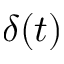<formula> <loc_0><loc_0><loc_500><loc_500>\delta ( t )</formula> 